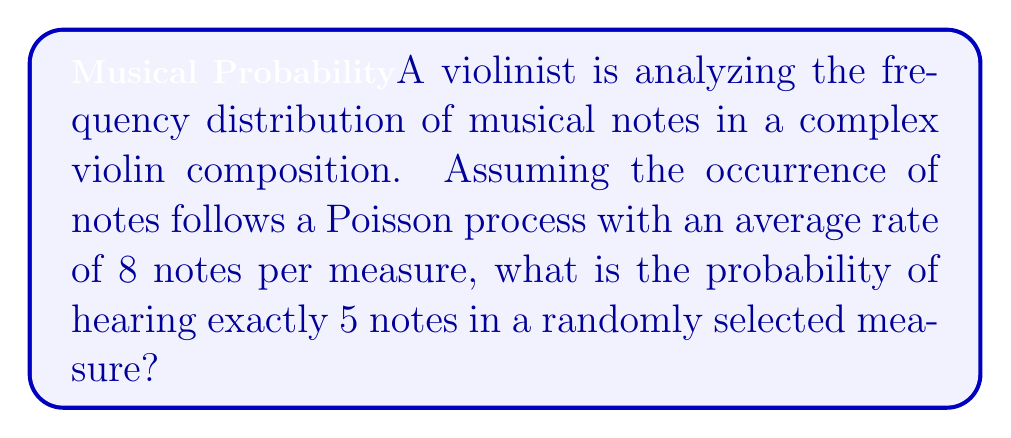Can you answer this question? To solve this problem, we'll use the Poisson distribution formula:

$$P(X = k) = \frac{e^{-\lambda} \lambda^k}{k!}$$

Where:
$\lambda$ = average rate of occurrence
$k$ = number of occurrences we're interested in
$e$ = Euler's number (approximately 2.71828)

Given:
$\lambda = 8$ (average of 8 notes per measure)
$k = 5$ (we want exactly 5 notes)

Step 1: Substitute the values into the Poisson distribution formula.
$$P(X = 5) = \frac{e^{-8} 8^5}{5!}$$

Step 2: Calculate $8^5$.
$$8^5 = 32,768$$

Step 3: Calculate $5!$.
$$5! = 5 \times 4 \times 3 \times 2 \times 1 = 120$$

Step 4: Calculate $e^{-8}$ (using a calculator).
$$e^{-8} \approx 0.000335$$

Step 5: Put it all together and calculate the final probability.
$$P(X = 5) = \frac{0.000335 \times 32,768}{120} \approx 0.0912$$

Therefore, the probability of hearing exactly 5 notes in a randomly selected measure is approximately 0.0912 or 9.12%.
Answer: 0.0912 